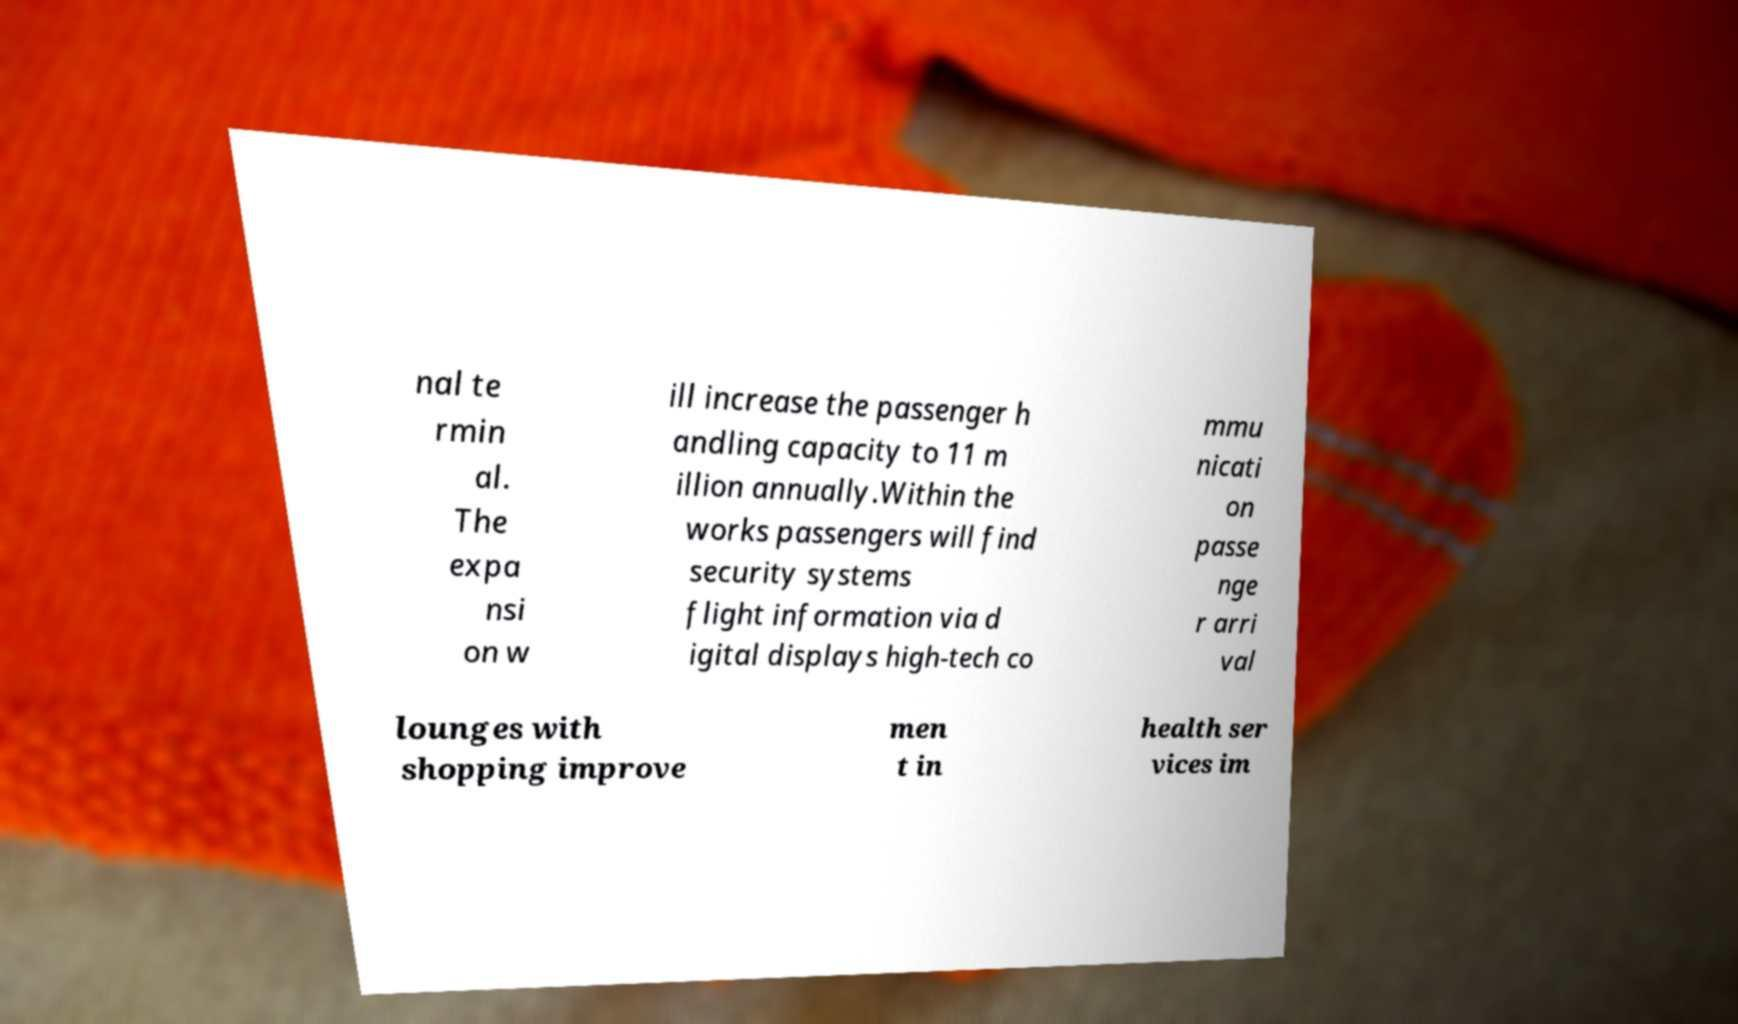Could you assist in decoding the text presented in this image and type it out clearly? nal te rmin al. The expa nsi on w ill increase the passenger h andling capacity to 11 m illion annually.Within the works passengers will find security systems flight information via d igital displays high-tech co mmu nicati on passe nge r arri val lounges with shopping improve men t in health ser vices im 